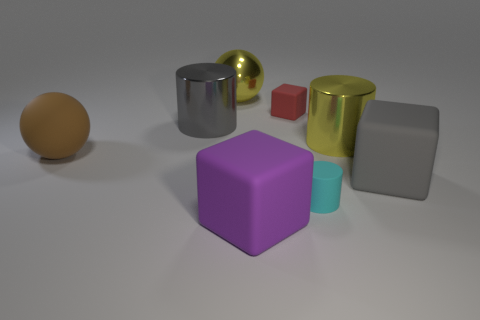What textures are present in the objects depicted? The objects in the image feature a variety of textures. The brown sphere on the left seems to have a smooth, perhaps slightly matte finish. The metallic cylinder and the golden sphere have reflective, shiny surfaces. The tiny red cube and the large gray block display matte textures. Lastly, the purple cube in the foreground and the small teal cylinder appear to have less reflective, more velvety surfaces. 